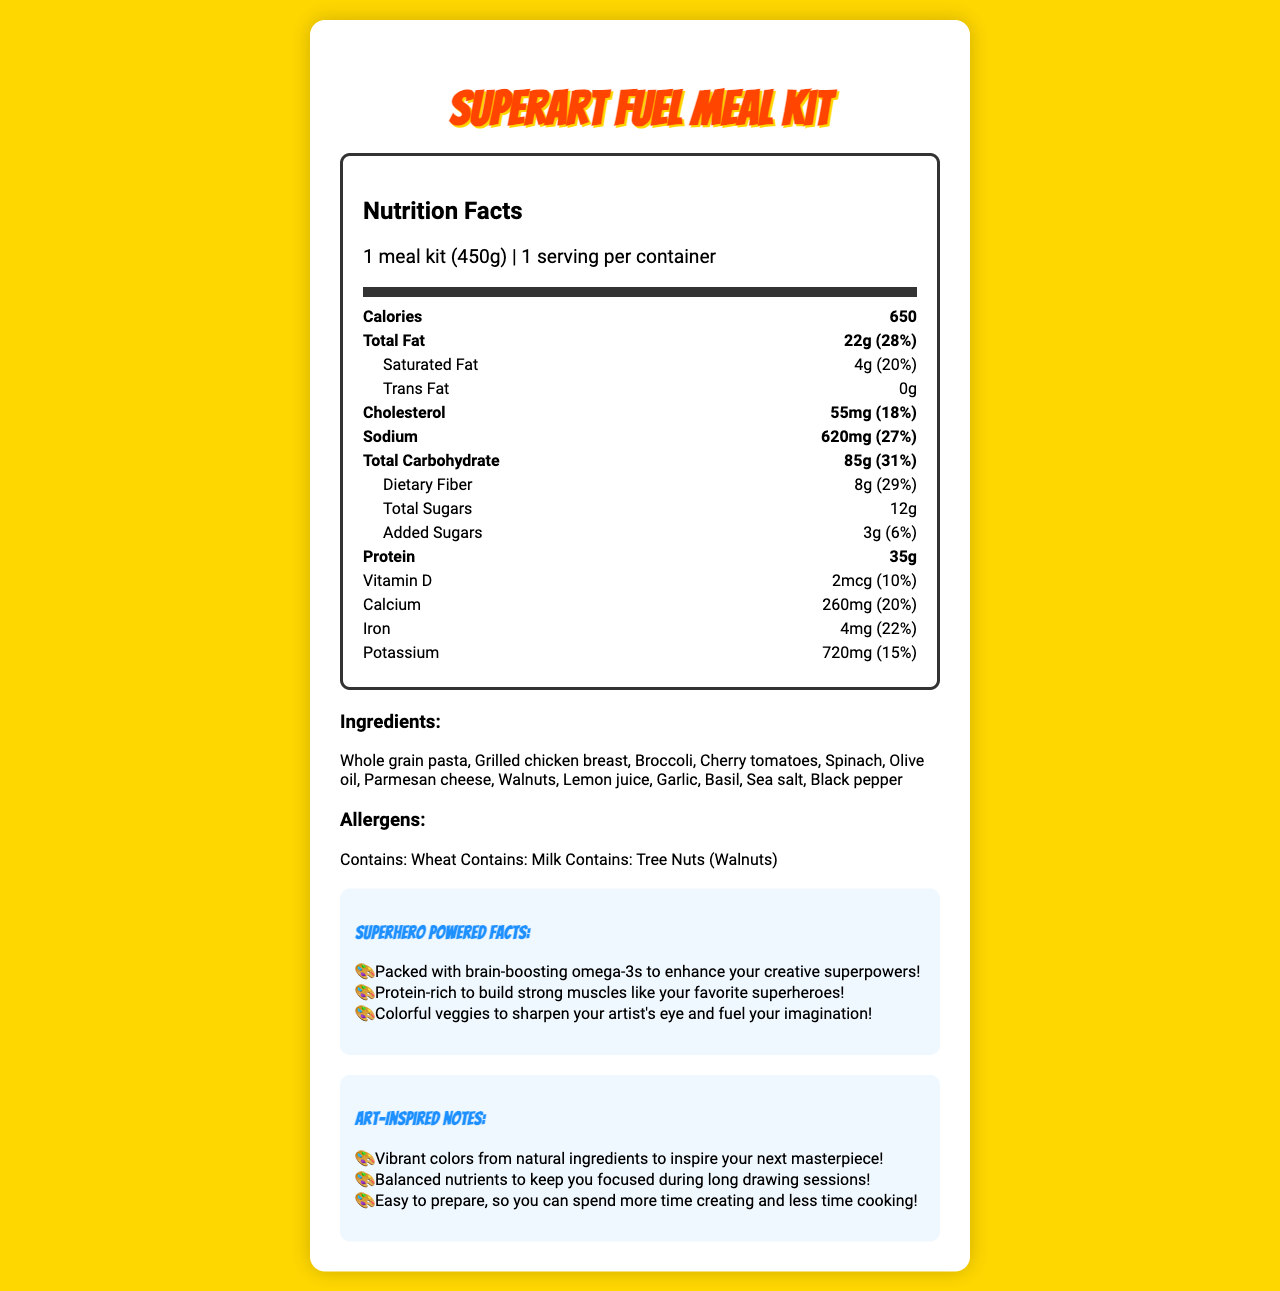what is the serving size? The serving size is explicitly stated at the beginning of the Nutrition Facts section.
Answer: 1 meal kit (450g) how many calories does the meal kit provide? The calories information is highlighted in the bold section in the Nutrition Facts.
Answer: 650 what is the amount of protein in the meal kit? The amount of protein can be found in the bold section of the Nutrition Facts under "Protein."
Answer: 35g what is the total fat content, and what percentage of the daily value does it represent? The total fat content and its daily value percentage are listed in the bold section of the Nutrition Facts under "Total Fat."
Answer: 22g, 28% which vitamins are included in the meal kit, and what are their daily value percentages? These details are listed under their respective nutrient names in the Nutrition Facts section.
Answer: Vitamin D (10%), Calcium (20%), Iron (22%), Potassium (15%), Vitamin A (33%), Vitamin C (50%), Vitamin E (33%), Vitamin B12 (63%) how much dietary fiber is in the meal kit, and what percentage of the daily value does this represent? The dietary fiber content and its daily value percentage are listed under "Dietary Fiber" in the indented section of Total Carbohydrate.
Answer: 8g, 29% which ingredients in the meal kit contain potential allergens? The allergens are listed in the Allergens section near the end of the document.
Answer: Wheat, Milk, Tree Nuts (Walnuts) what are the benefits of the omega-3 content mentioned in the document's superhero facts? A. Enhances creative superpowers B. Builds strong muscles C. Sharpens artist's eye D. Keeps you focused during long drawing sessions One of the superhero facts states that omega-3s are packed to enhance creative superpowers.
Answer: A. Enhances creative superpowers which ingredient is NOT part of the SuperArt Fuel Meal Kit? A. Grilled chicken breast B. Whole grain pasta C. Cauliflower D. Cherry tomatoes Cauliflower is not listed among the ingredients of the meal kit.
Answer: C. Cauliflower does the meal kit contain any trans fat? The trans fat content is listed as 0g in the Nutrition Facts.
Answer: No summarize the main idea of the SuperArt Fuel Meal Kit's document. The summary includes key points about nutrition, ingredients, benefits, allergens, and the primary purpose of the meal kit based on the document's content.
Answer: The SuperArt Fuel Meal Kit's document provides nutritional information, ingredients, and benefits designed for young artists. It emphasizes balanced nutrients to support long creative sessions, highlights superhero-themed benefits like brain-boosting omega-3s and protein for muscle growth, and promotes colorful veggies for inspiration. It also lists potential allergens and easy preparation notes. what is the origin of the whole grain pasta used in the meal kit? The document does not provide details about the origin of the whole grain pasta.
Answer: Not enough information 